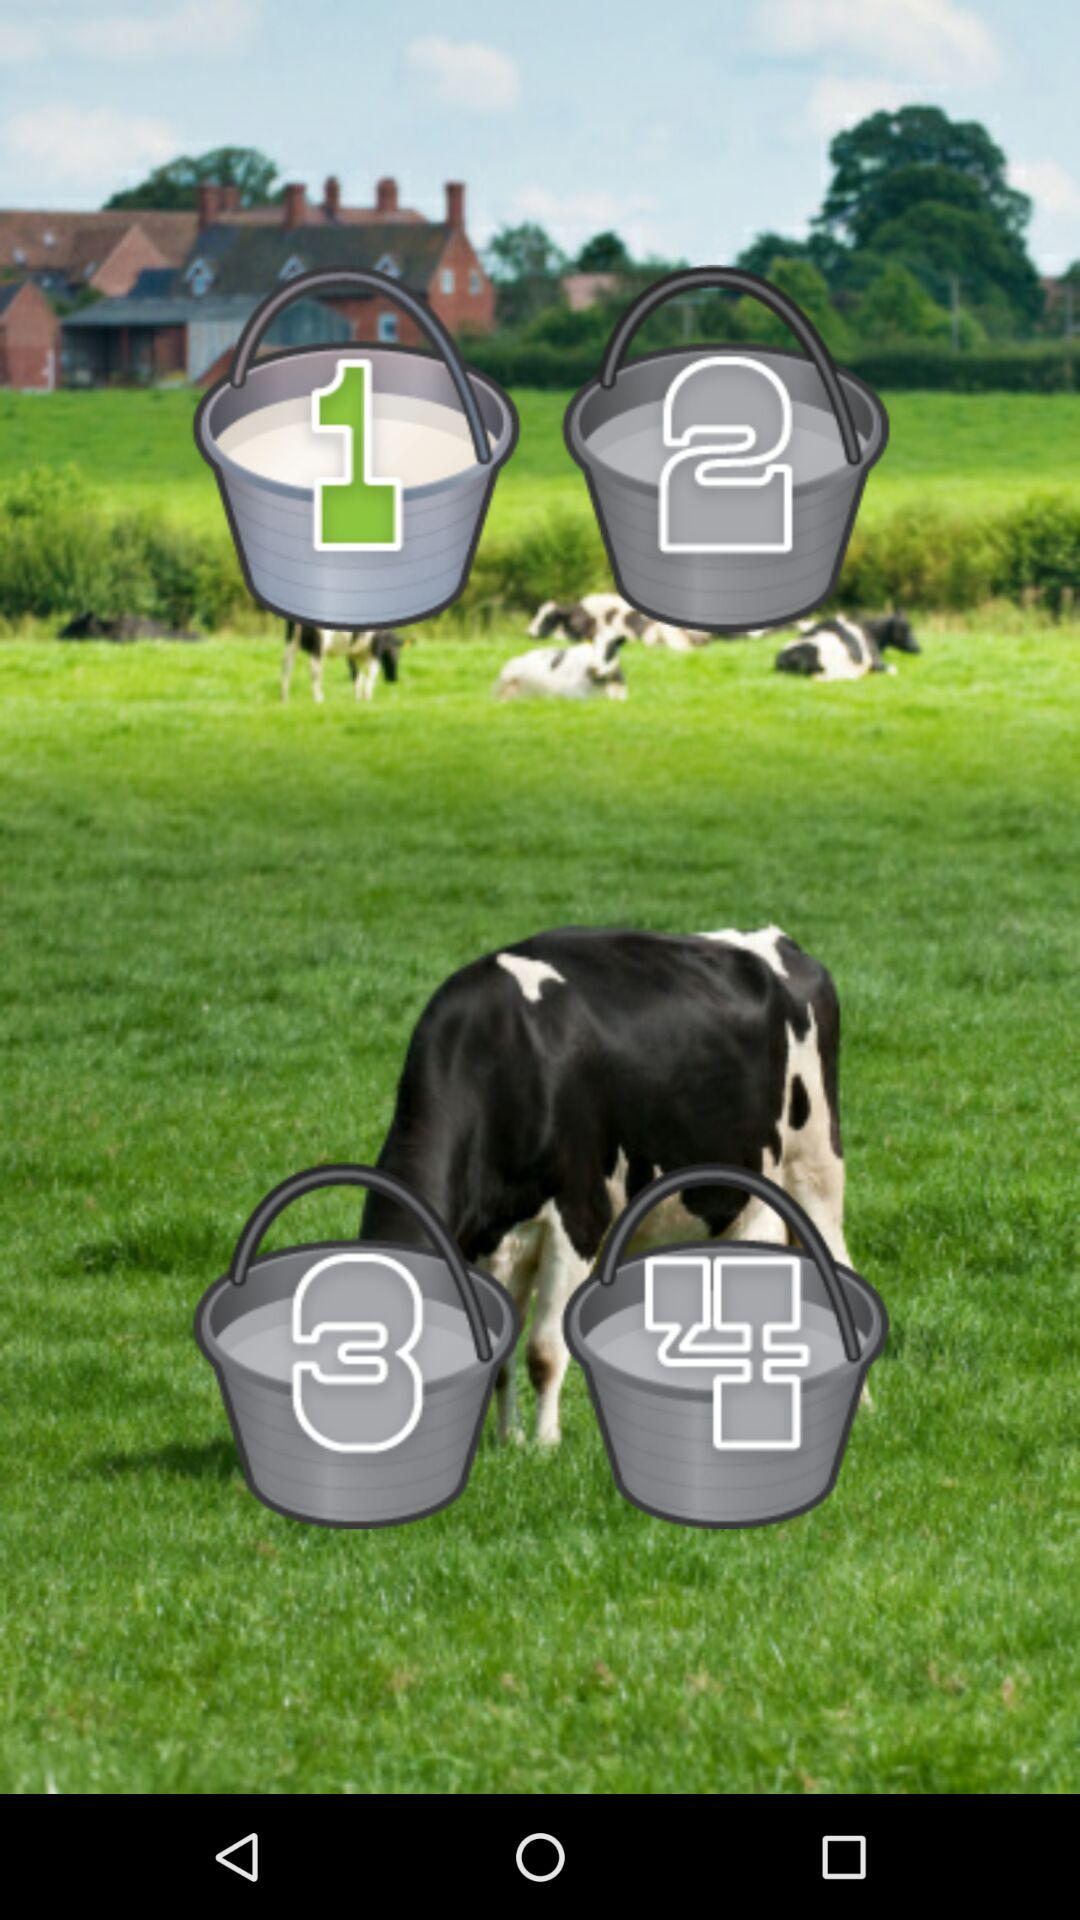How many buckets of milk have the number 3 on them?
Answer the question using a single word or phrase. 1 